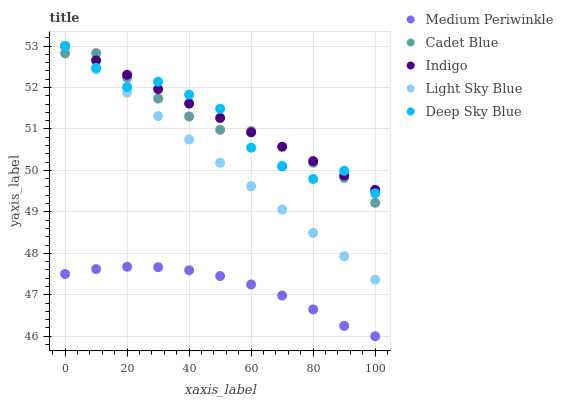Does Medium Periwinkle have the minimum area under the curve?
Answer yes or no. Yes. Does Indigo have the maximum area under the curve?
Answer yes or no. Yes. Does Cadet Blue have the minimum area under the curve?
Answer yes or no. No. Does Cadet Blue have the maximum area under the curve?
Answer yes or no. No. Is Indigo the smoothest?
Answer yes or no. Yes. Is Cadet Blue the roughest?
Answer yes or no. Yes. Is Medium Periwinkle the smoothest?
Answer yes or no. No. Is Medium Periwinkle the roughest?
Answer yes or no. No. Does Medium Periwinkle have the lowest value?
Answer yes or no. Yes. Does Cadet Blue have the lowest value?
Answer yes or no. No. Does Light Sky Blue have the highest value?
Answer yes or no. Yes. Does Cadet Blue have the highest value?
Answer yes or no. No. Is Medium Periwinkle less than Indigo?
Answer yes or no. Yes. Is Cadet Blue greater than Medium Periwinkle?
Answer yes or no. Yes. Does Light Sky Blue intersect Cadet Blue?
Answer yes or no. Yes. Is Light Sky Blue less than Cadet Blue?
Answer yes or no. No. Is Light Sky Blue greater than Cadet Blue?
Answer yes or no. No. Does Medium Periwinkle intersect Indigo?
Answer yes or no. No. 